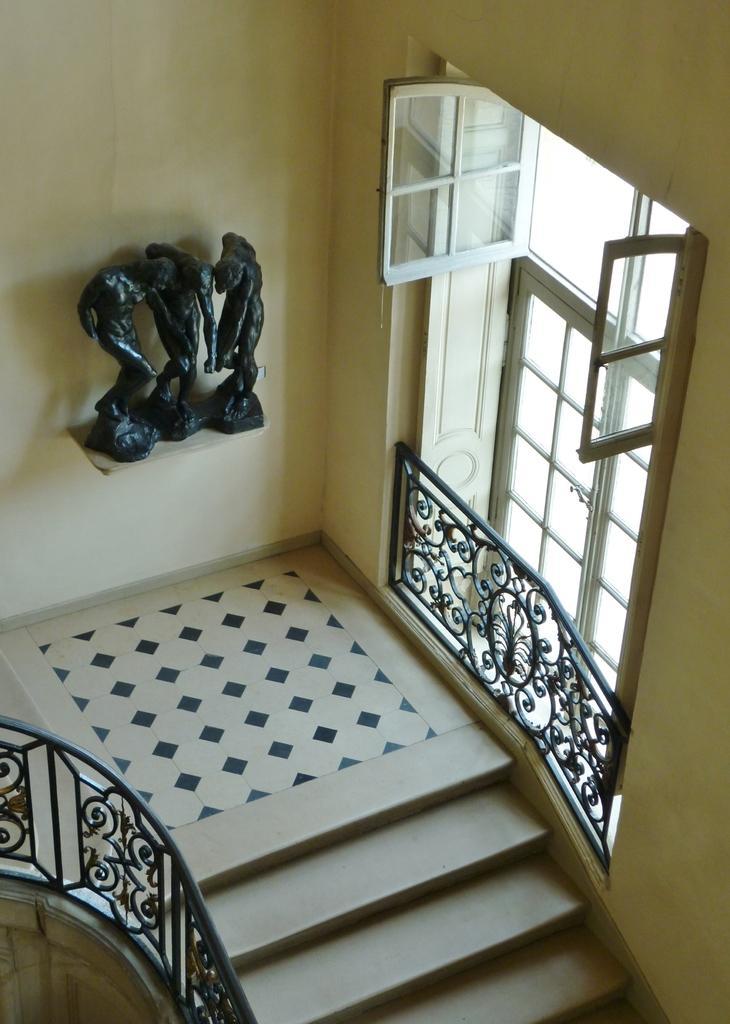Describe this image in one or two sentences. In the image we can see there are stairs and there are iron railings. There are windows on the wall and there are human statues kept on the wall stand. 